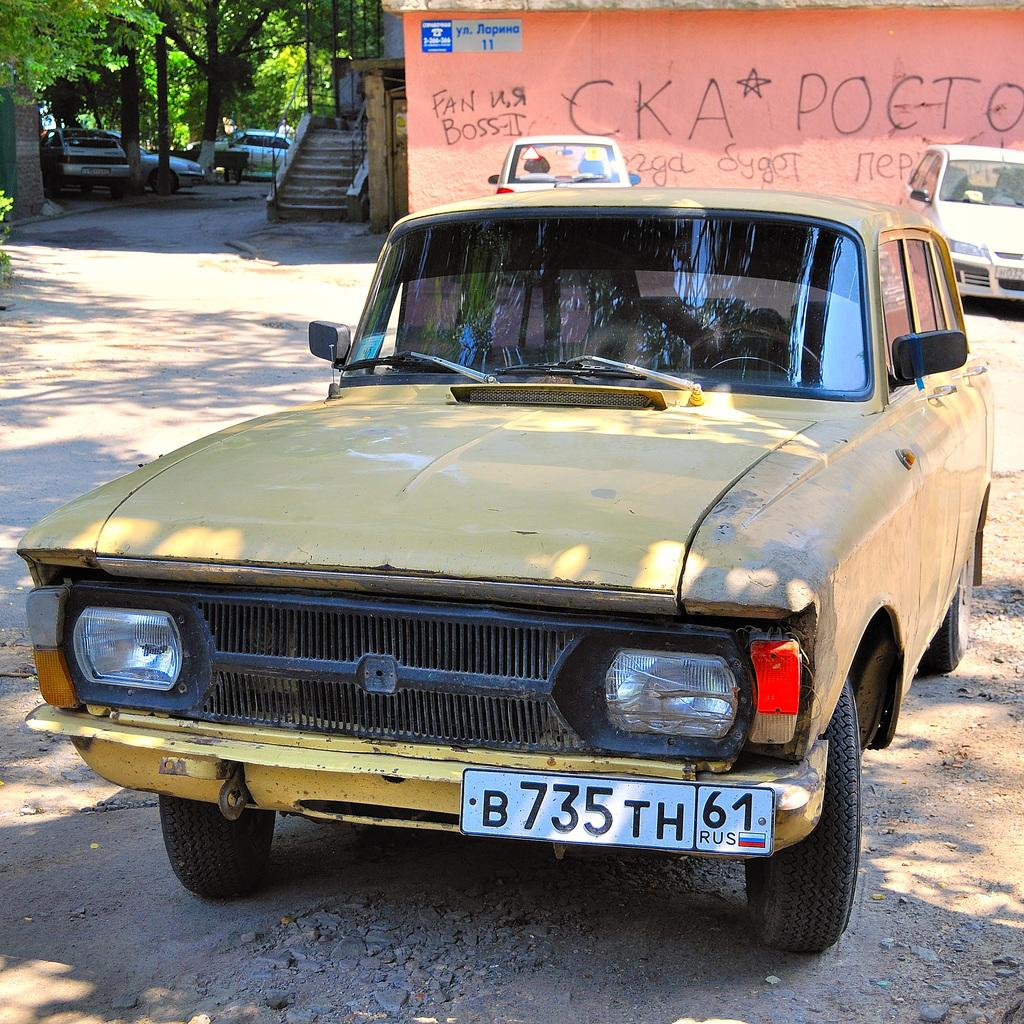Provide a one-sentence caption for the provided image. The old yellow car has a Russian tag B735TH. 